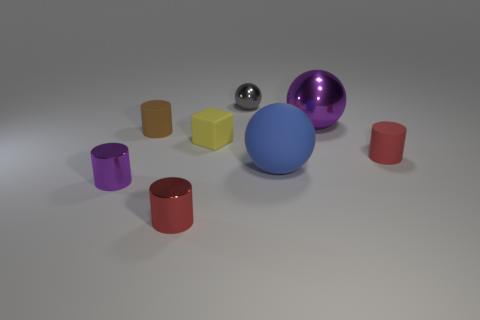The tiny metallic object that is behind the ball in front of the red rubber object is what color?
Provide a succinct answer. Gray. What is the cylinder that is behind the tiny matte cube made of?
Offer a terse response. Rubber. Are there fewer tiny yellow rubber things than big spheres?
Keep it short and to the point. Yes. Does the blue matte thing have the same shape as the purple thing on the right side of the gray metal thing?
Your answer should be compact. Yes. What shape is the shiny object that is in front of the gray ball and behind the small purple cylinder?
Give a very brief answer. Sphere. Is the number of things in front of the small yellow block the same as the number of large objects that are behind the big rubber sphere?
Provide a short and direct response. No. There is a purple object that is on the right side of the gray sphere; is it the same shape as the blue thing?
Offer a very short reply. Yes. What number of yellow things are cubes or tiny shiny cylinders?
Your answer should be very brief. 1. What is the material of the blue object that is the same shape as the small gray metallic thing?
Your response must be concise. Rubber. The purple metal object to the right of the tiny purple metal object has what shape?
Your answer should be compact. Sphere. 